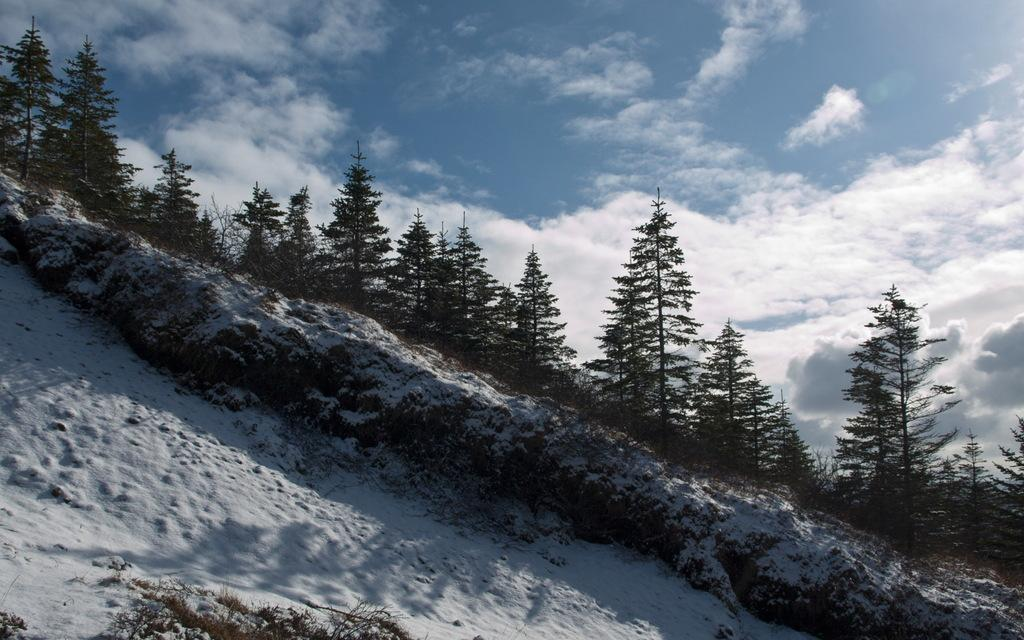What type of weather is depicted in the image? The image shows snow at the bottom, indicating a winter scene. What can be seen in the background of the image? There are trees in the background of the image. What is visible at the top of the image? The sky is visible at the top of the image. What is the condition of the sky in the image? Clouds are present in the sky. What is the income of the servant in the image? There is no servant or income mentioned in the image; it features a snowy scene with trees and a cloudy sky. 